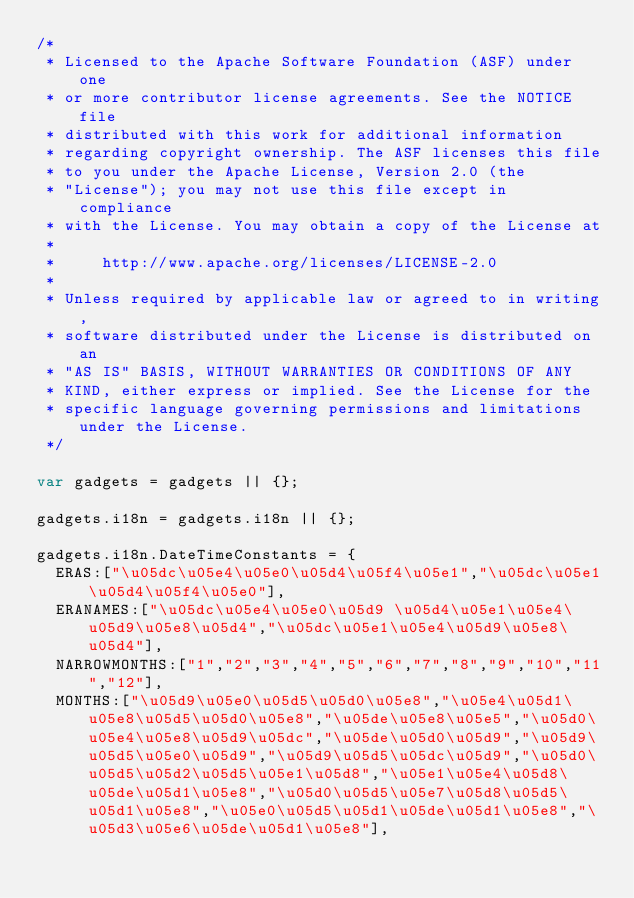<code> <loc_0><loc_0><loc_500><loc_500><_JavaScript_>/*
 * Licensed to the Apache Software Foundation (ASF) under one
 * or more contributor license agreements. See the NOTICE file
 * distributed with this work for additional information
 * regarding copyright ownership. The ASF licenses this file
 * to you under the Apache License, Version 2.0 (the
 * "License"); you may not use this file except in compliance
 * with the License. You may obtain a copy of the License at
 *
 *     http://www.apache.org/licenses/LICENSE-2.0
 *
 * Unless required by applicable law or agreed to in writing,
 * software distributed under the License is distributed on an
 * "AS IS" BASIS, WITHOUT WARRANTIES OR CONDITIONS OF ANY
 * KIND, either express or implied. See the License for the
 * specific language governing permissions and limitations under the License.
 */

var gadgets = gadgets || {};

gadgets.i18n = gadgets.i18n || {};

gadgets.i18n.DateTimeConstants = {
  ERAS:["\u05dc\u05e4\u05e0\u05d4\u05f4\u05e1","\u05dc\u05e1\u05d4\u05f4\u05e0"],
  ERANAMES:["\u05dc\u05e4\u05e0\u05d9 \u05d4\u05e1\u05e4\u05d9\u05e8\u05d4","\u05dc\u05e1\u05e4\u05d9\u05e8\u05d4"],
  NARROWMONTHS:["1","2","3","4","5","6","7","8","9","10","11","12"],
  MONTHS:["\u05d9\u05e0\u05d5\u05d0\u05e8","\u05e4\u05d1\u05e8\u05d5\u05d0\u05e8","\u05de\u05e8\u05e5","\u05d0\u05e4\u05e8\u05d9\u05dc","\u05de\u05d0\u05d9","\u05d9\u05d5\u05e0\u05d9","\u05d9\u05d5\u05dc\u05d9","\u05d0\u05d5\u05d2\u05d5\u05e1\u05d8","\u05e1\u05e4\u05d8\u05de\u05d1\u05e8","\u05d0\u05d5\u05e7\u05d8\u05d5\u05d1\u05e8","\u05e0\u05d5\u05d1\u05de\u05d1\u05e8","\u05d3\u05e6\u05de\u05d1\u05e8"],</code> 